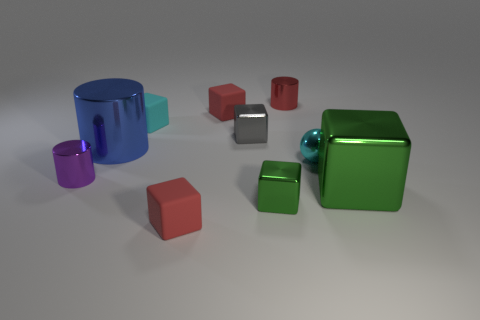Subtract 3 blocks. How many blocks are left? 3 Subtract all red cubes. How many cubes are left? 4 Subtract all large cubes. How many cubes are left? 5 Subtract all purple blocks. Subtract all red cylinders. How many blocks are left? 6 Subtract all cylinders. How many objects are left? 7 Subtract 0 blue cubes. How many objects are left? 10 Subtract all big green things. Subtract all small gray blocks. How many objects are left? 8 Add 2 tiny cylinders. How many tiny cylinders are left? 4 Add 4 tiny cyan balls. How many tiny cyan balls exist? 5 